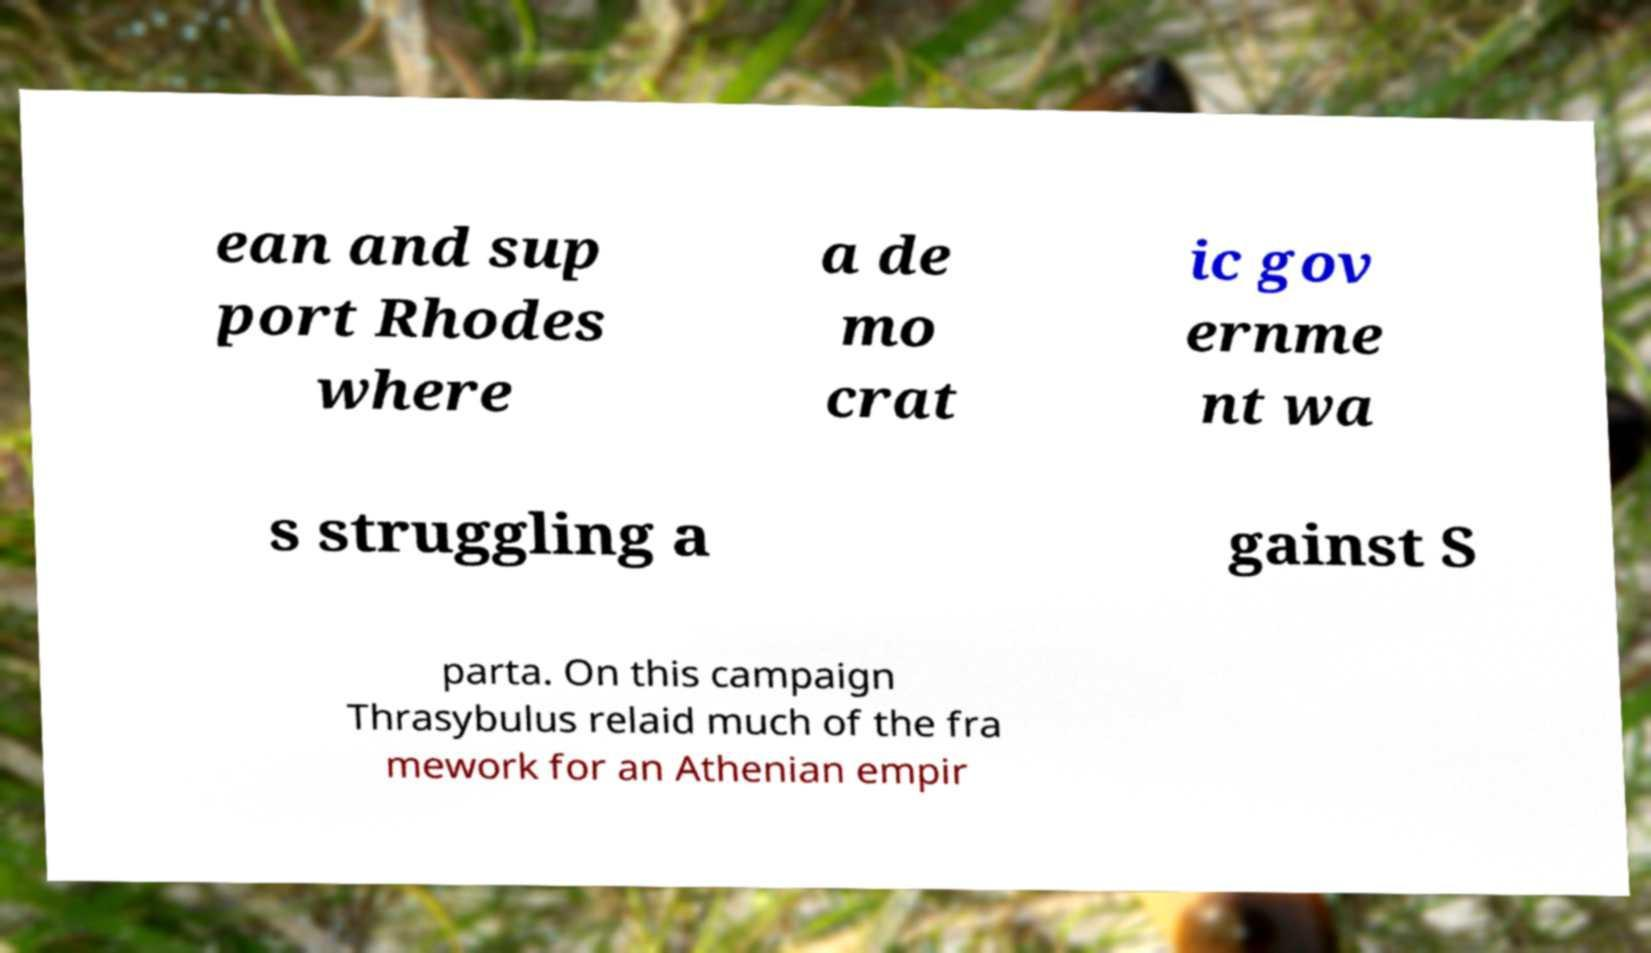Could you assist in decoding the text presented in this image and type it out clearly? ean and sup port Rhodes where a de mo crat ic gov ernme nt wa s struggling a gainst S parta. On this campaign Thrasybulus relaid much of the fra mework for an Athenian empir 